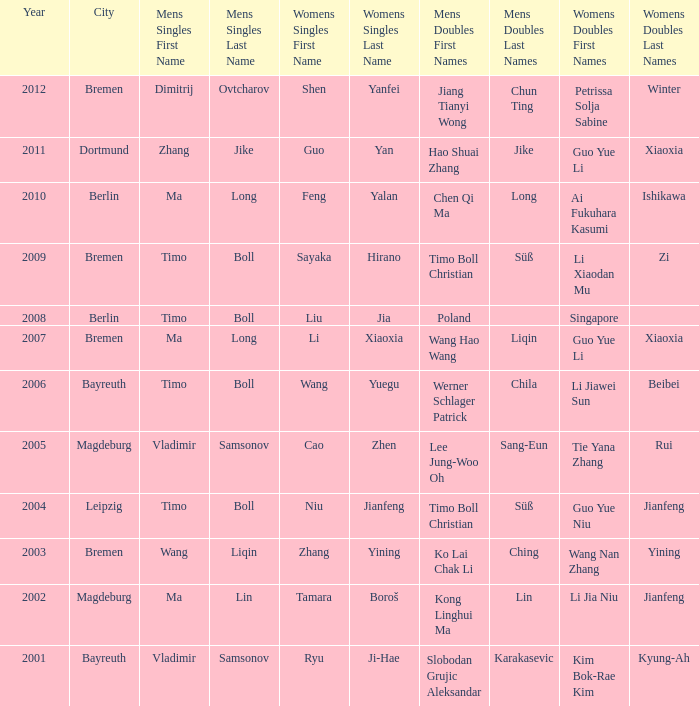Who won Womens Singles in the year that Ma Lin won Mens Singles? Tamara Boroš. 